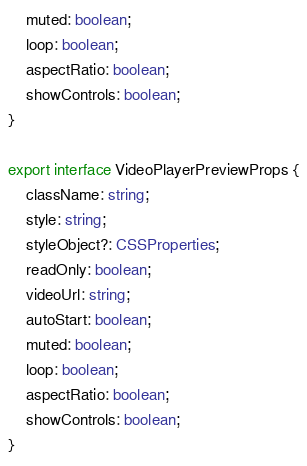<code> <loc_0><loc_0><loc_500><loc_500><_TypeScript_>    muted: boolean;
    loop: boolean;
    aspectRatio: boolean;
    showControls: boolean;
}

export interface VideoPlayerPreviewProps {
    className: string;
    style: string;
    styleObject?: CSSProperties;
    readOnly: boolean;
    videoUrl: string;
    autoStart: boolean;
    muted: boolean;
    loop: boolean;
    aspectRatio: boolean;
    showControls: boolean;
}
</code> 